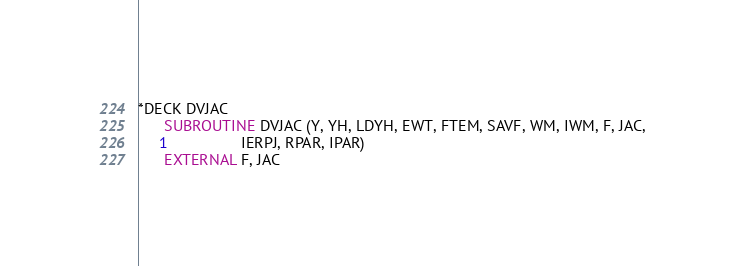<code> <loc_0><loc_0><loc_500><loc_500><_FORTRAN_>*DECK DVJAC
      SUBROUTINE DVJAC (Y, YH, LDYH, EWT, FTEM, SAVF, WM, IWM, F, JAC,
     1                 IERPJ, RPAR, IPAR)
      EXTERNAL F, JAC</code> 